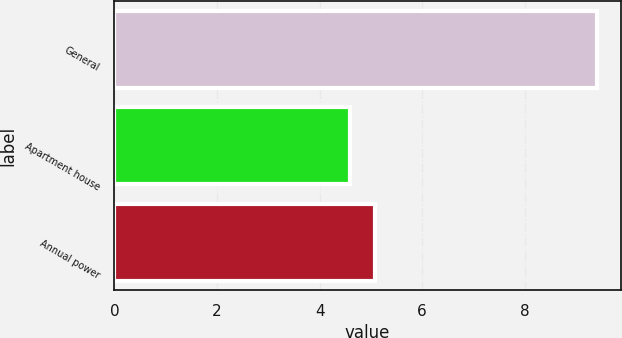Convert chart. <chart><loc_0><loc_0><loc_500><loc_500><bar_chart><fcel>General<fcel>Apartment house<fcel>Annual power<nl><fcel>9.4<fcel>4.6<fcel>5.08<nl></chart> 